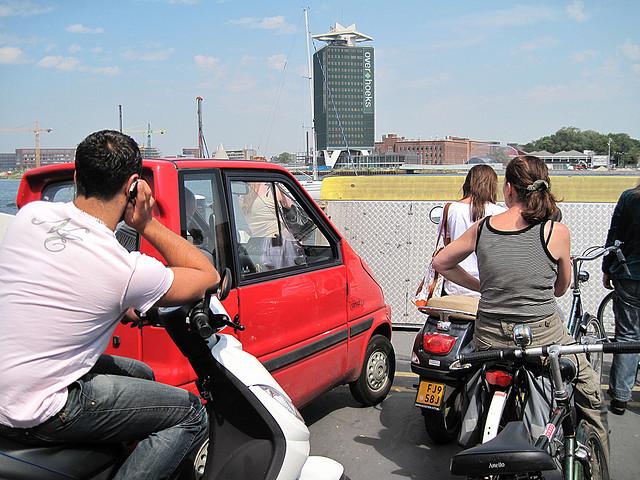What is the man on the left holding to his ear?
Give a very brief answer. Phone. Are they wearing helmets?
Short answer required. No. Is this picture taken during the day or night?
Answer briefly. Day. What is the woman straddling?
Keep it brief. Bike. How many girls are there?
Keep it brief. 2. What color is the car in the picture?
Be succinct. Red. 